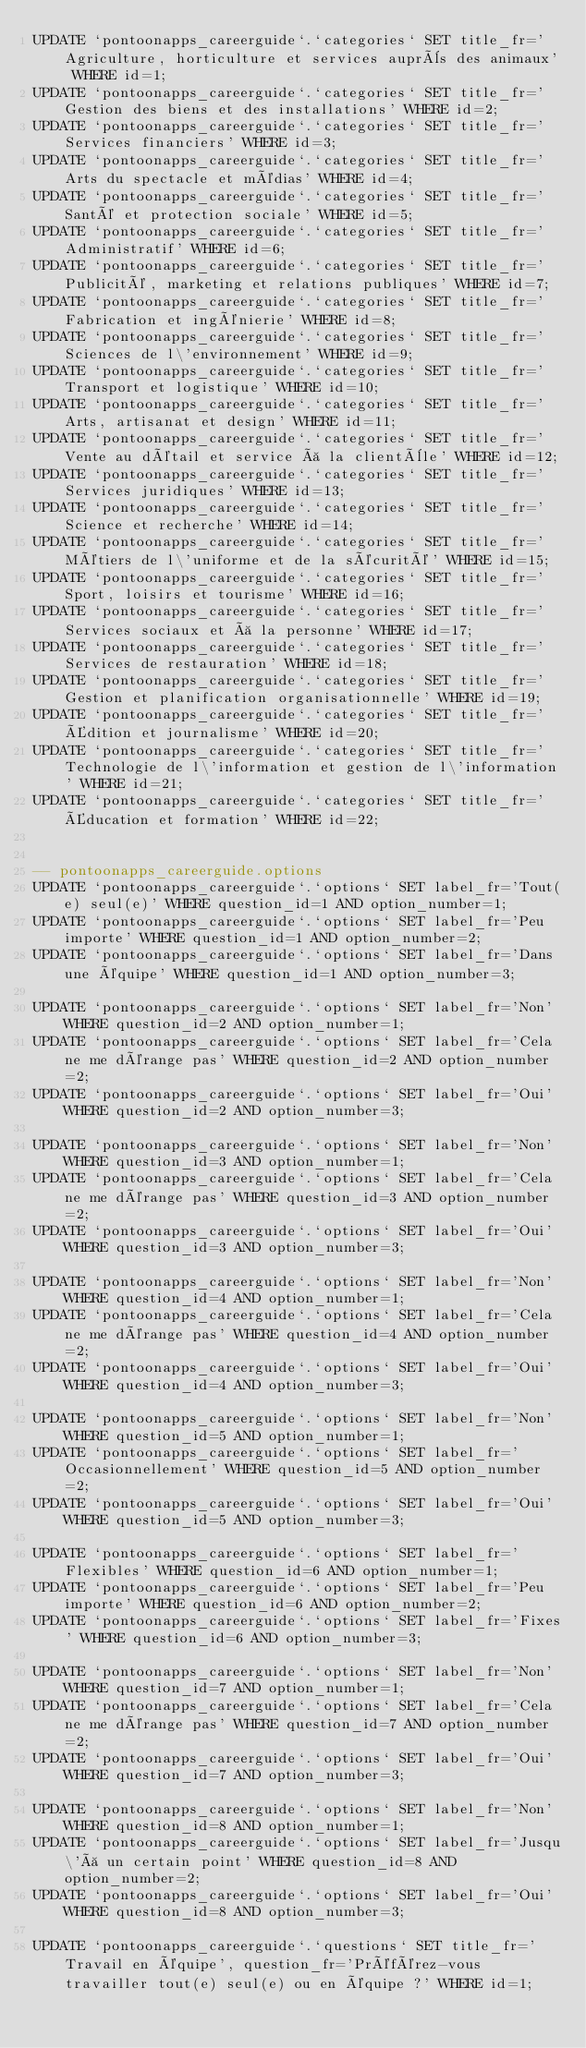Convert code to text. <code><loc_0><loc_0><loc_500><loc_500><_SQL_>UPDATE `pontoonapps_careerguide`.`categories` SET title_fr='Agriculture, horticulture et services auprès des animaux' WHERE id=1;
UPDATE `pontoonapps_careerguide`.`categories` SET title_fr='Gestion des biens et des installations' WHERE id=2;
UPDATE `pontoonapps_careerguide`.`categories` SET title_fr='Services financiers' WHERE id=3;
UPDATE `pontoonapps_careerguide`.`categories` SET title_fr='Arts du spectacle et médias' WHERE id=4;
UPDATE `pontoonapps_careerguide`.`categories` SET title_fr='Santé et protection sociale' WHERE id=5;
UPDATE `pontoonapps_careerguide`.`categories` SET title_fr='Administratif' WHERE id=6;
UPDATE `pontoonapps_careerguide`.`categories` SET title_fr='Publicité, marketing et relations publiques' WHERE id=7;
UPDATE `pontoonapps_careerguide`.`categories` SET title_fr='Fabrication et ingénierie' WHERE id=8;
UPDATE `pontoonapps_careerguide`.`categories` SET title_fr='Sciences de l\'environnement' WHERE id=9;
UPDATE `pontoonapps_careerguide`.`categories` SET title_fr='Transport et logistique' WHERE id=10;
UPDATE `pontoonapps_careerguide`.`categories` SET title_fr='Arts, artisanat et design' WHERE id=11;
UPDATE `pontoonapps_careerguide`.`categories` SET title_fr='Vente au détail et service à la clientèle' WHERE id=12;
UPDATE `pontoonapps_careerguide`.`categories` SET title_fr='Services juridiques' WHERE id=13;
UPDATE `pontoonapps_careerguide`.`categories` SET title_fr='Science et recherche' WHERE id=14;
UPDATE `pontoonapps_careerguide`.`categories` SET title_fr='Métiers de l\'uniforme et de la sécurité' WHERE id=15;
UPDATE `pontoonapps_careerguide`.`categories` SET title_fr='Sport, loisirs et tourisme' WHERE id=16;
UPDATE `pontoonapps_careerguide`.`categories` SET title_fr='Services sociaux et à la personne' WHERE id=17;
UPDATE `pontoonapps_careerguide`.`categories` SET title_fr='Services de restauration' WHERE id=18;
UPDATE `pontoonapps_careerguide`.`categories` SET title_fr='Gestion et planification organisationnelle' WHERE id=19;
UPDATE `pontoonapps_careerguide`.`categories` SET title_fr='Édition et journalisme' WHERE id=20;
UPDATE `pontoonapps_careerguide`.`categories` SET title_fr='Technologie de l\'information et gestion de l\'information' WHERE id=21;
UPDATE `pontoonapps_careerguide`.`categories` SET title_fr='Éducation et formation' WHERE id=22;


-- pontoonapps_careerguide.options
UPDATE `pontoonapps_careerguide`.`options` SET label_fr='Tout(e) seul(e)' WHERE question_id=1 AND option_number=1;
UPDATE `pontoonapps_careerguide`.`options` SET label_fr='Peu importe' WHERE question_id=1 AND option_number=2;
UPDATE `pontoonapps_careerguide`.`options` SET label_fr='Dans une équipe' WHERE question_id=1 AND option_number=3;

UPDATE `pontoonapps_careerguide`.`options` SET label_fr='Non' WHERE question_id=2 AND option_number=1;
UPDATE `pontoonapps_careerguide`.`options` SET label_fr='Cela ne me dérange pas' WHERE question_id=2 AND option_number=2;
UPDATE `pontoonapps_careerguide`.`options` SET label_fr='Oui' WHERE question_id=2 AND option_number=3;

UPDATE `pontoonapps_careerguide`.`options` SET label_fr='Non' WHERE question_id=3 AND option_number=1;
UPDATE `pontoonapps_careerguide`.`options` SET label_fr='Cela ne me dérange pas' WHERE question_id=3 AND option_number=2;
UPDATE `pontoonapps_careerguide`.`options` SET label_fr='Oui' WHERE question_id=3 AND option_number=3;

UPDATE `pontoonapps_careerguide`.`options` SET label_fr='Non' WHERE question_id=4 AND option_number=1;
UPDATE `pontoonapps_careerguide`.`options` SET label_fr='Cela ne me dérange pas' WHERE question_id=4 AND option_number=2;
UPDATE `pontoonapps_careerguide`.`options` SET label_fr='Oui' WHERE question_id=4 AND option_number=3;

UPDATE `pontoonapps_careerguide`.`options` SET label_fr='Non' WHERE question_id=5 AND option_number=1;
UPDATE `pontoonapps_careerguide`.`options` SET label_fr='Occasionnellement' WHERE question_id=5 AND option_number=2;
UPDATE `pontoonapps_careerguide`.`options` SET label_fr='Oui' WHERE question_id=5 AND option_number=3;

UPDATE `pontoonapps_careerguide`.`options` SET label_fr='Flexibles' WHERE question_id=6 AND option_number=1;
UPDATE `pontoonapps_careerguide`.`options` SET label_fr='Peu importe' WHERE question_id=6 AND option_number=2;
UPDATE `pontoonapps_careerguide`.`options` SET label_fr='Fixes' WHERE question_id=6 AND option_number=3;

UPDATE `pontoonapps_careerguide`.`options` SET label_fr='Non' WHERE question_id=7 AND option_number=1;
UPDATE `pontoonapps_careerguide`.`options` SET label_fr='Cela ne me dérange pas' WHERE question_id=7 AND option_number=2;
UPDATE `pontoonapps_careerguide`.`options` SET label_fr='Oui' WHERE question_id=7 AND option_number=3;

UPDATE `pontoonapps_careerguide`.`options` SET label_fr='Non' WHERE question_id=8 AND option_number=1;
UPDATE `pontoonapps_careerguide`.`options` SET label_fr='Jusqu\'à un certain point' WHERE question_id=8 AND option_number=2;
UPDATE `pontoonapps_careerguide`.`options` SET label_fr='Oui' WHERE question_id=8 AND option_number=3;

UPDATE `pontoonapps_careerguide`.`questions` SET title_fr='Travail en équipe', question_fr='Préférez-vous travailler tout(e) seul(e) ou en équipe ?' WHERE id=1;</code> 